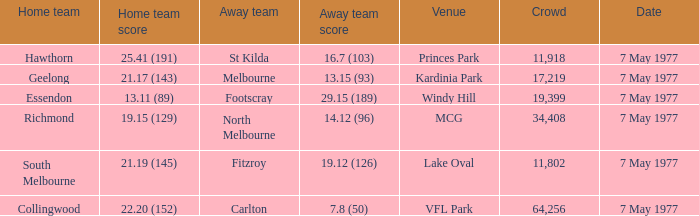What is the venue where geelong's home team plays? Kardinia Park. 